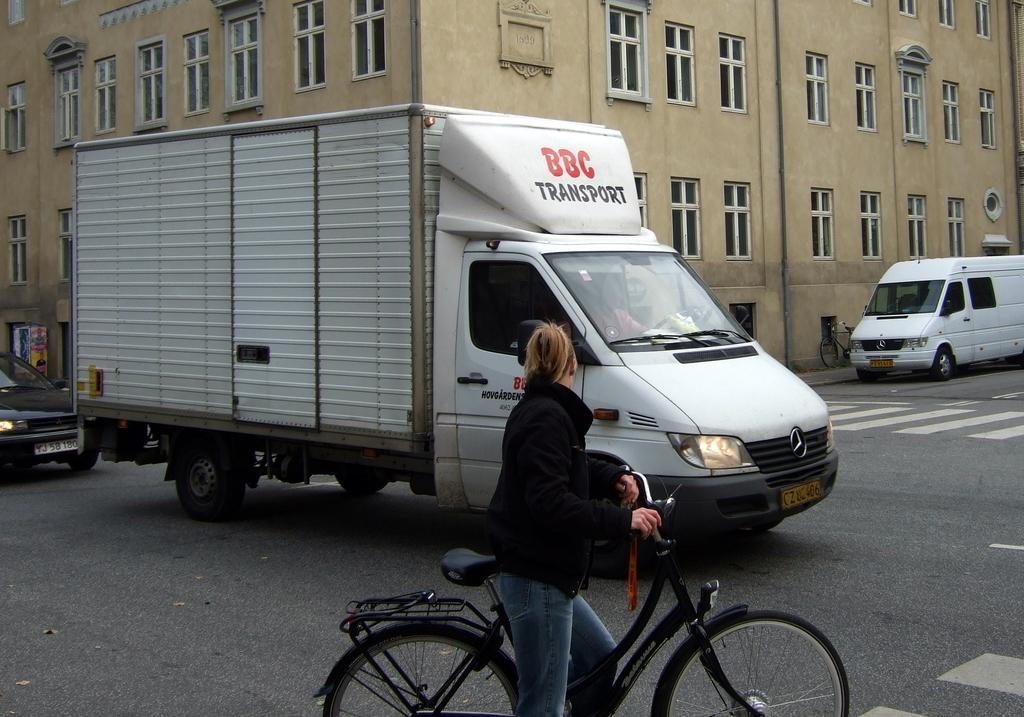Provide a one-sentence caption for the provided image. A woman on a bike staring at a white van labeled BBC Transportation. 